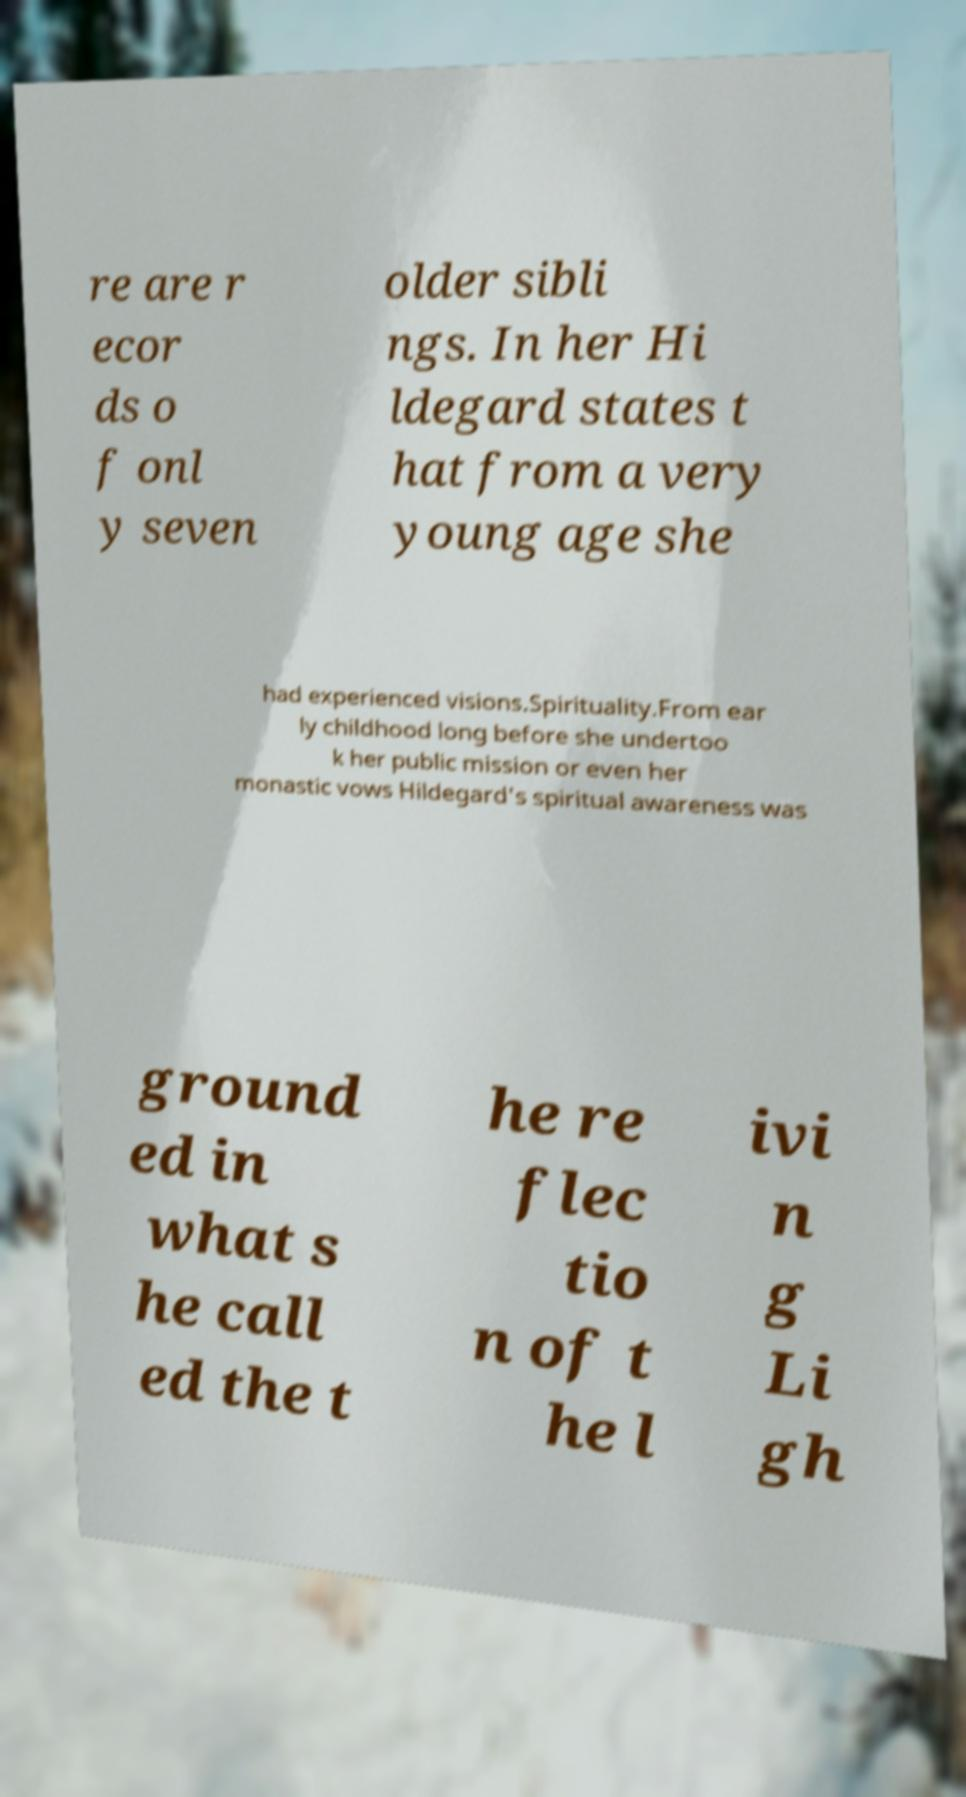Can you accurately transcribe the text from the provided image for me? re are r ecor ds o f onl y seven older sibli ngs. In her Hi ldegard states t hat from a very young age she had experienced visions.Spirituality.From ear ly childhood long before she undertoo k her public mission or even her monastic vows Hildegard's spiritual awareness was ground ed in what s he call ed the t he re flec tio n of t he l ivi n g Li gh 